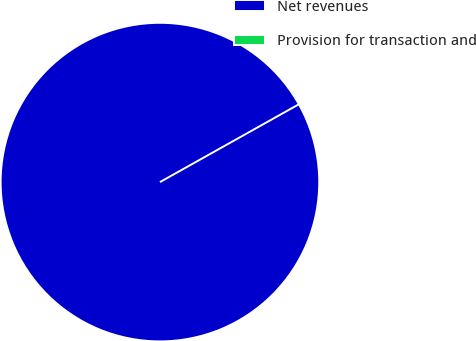Convert chart. <chart><loc_0><loc_0><loc_500><loc_500><pie_chart><fcel>Net revenues<fcel>Provision for transaction and<nl><fcel>100.0%<fcel>0.0%<nl></chart> 